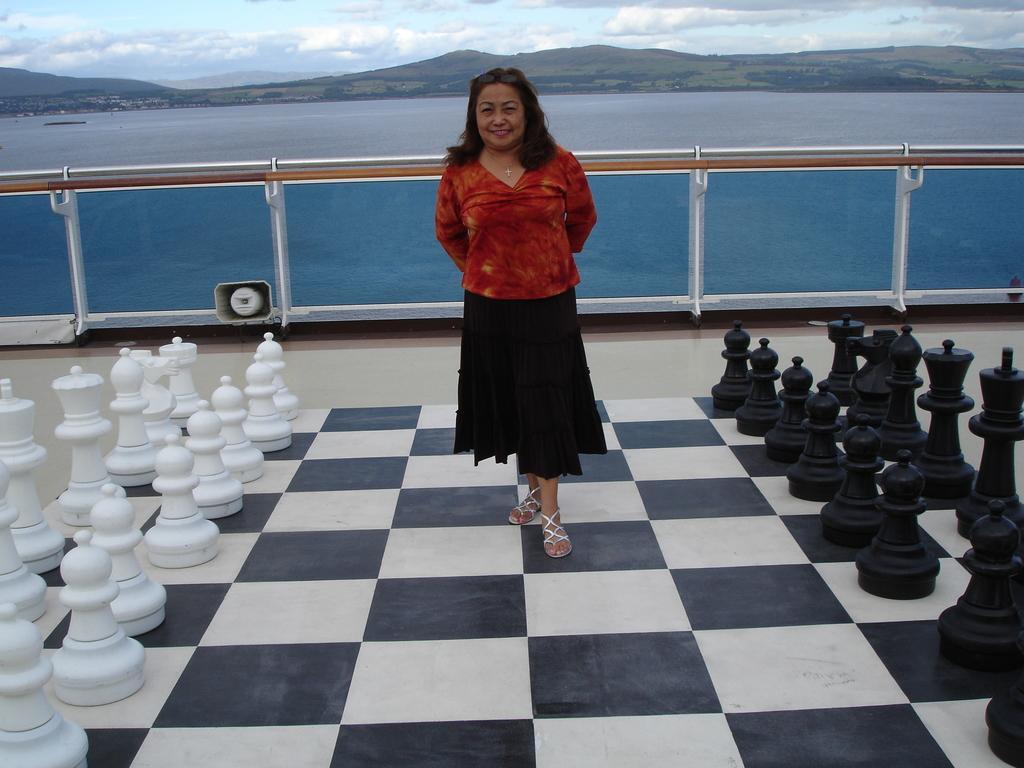In one or two sentences, can you explain what this image depicts? In this image we can see a woman wearing red color top, black color bottom standing in between the chess pieces and in the background of the image there is fencing, water, there are some mountains, cloudy sky. 